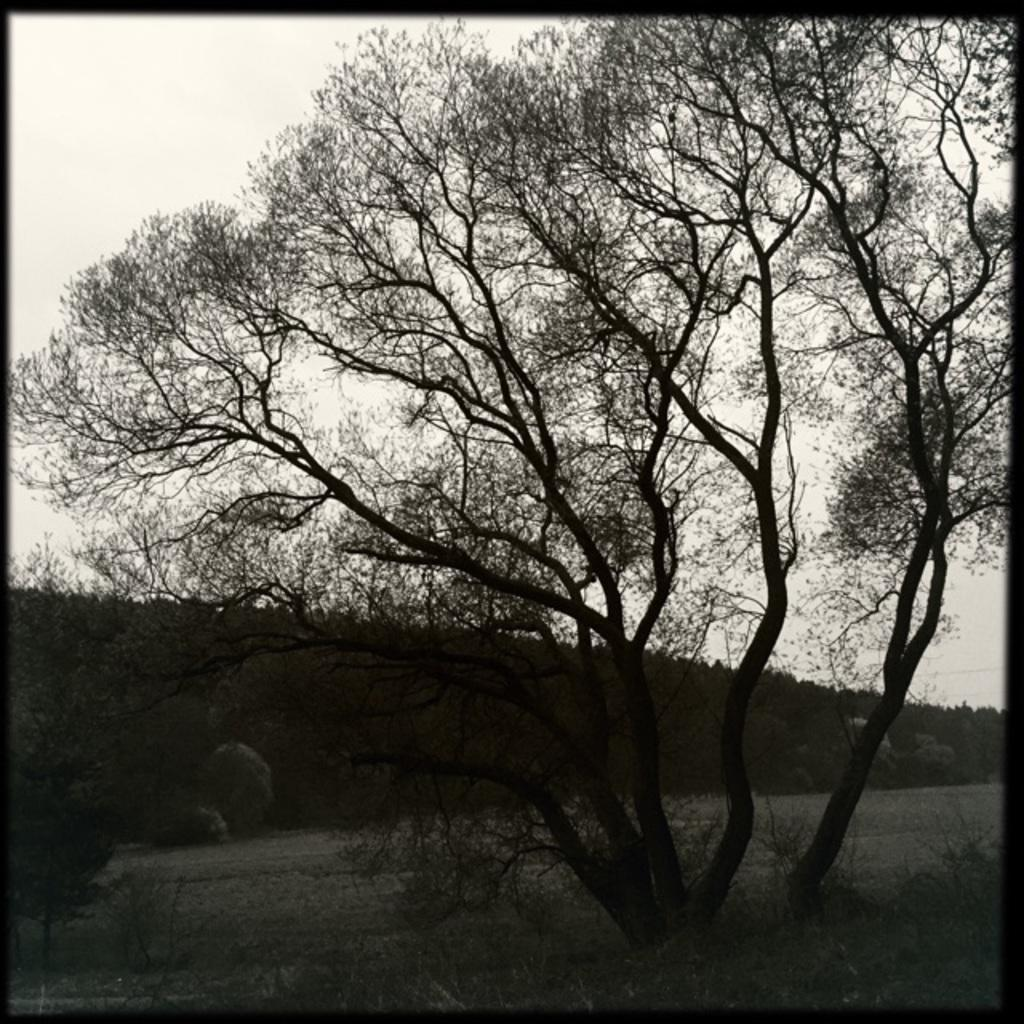What type of natural elements can be seen in the image? There are trees and rocks in the image. What man-made feature is present in the image? There is a path in the image. What is the terrain like in the image? There is a slope in the ground in the image. What is visible in the background of the image? The sky is visible in the image. Where is the vase placed in the image? There is no vase present in the image. What type of tool is being used by the person in the image? There is no person or tool, such as a wrench, present in the image. 